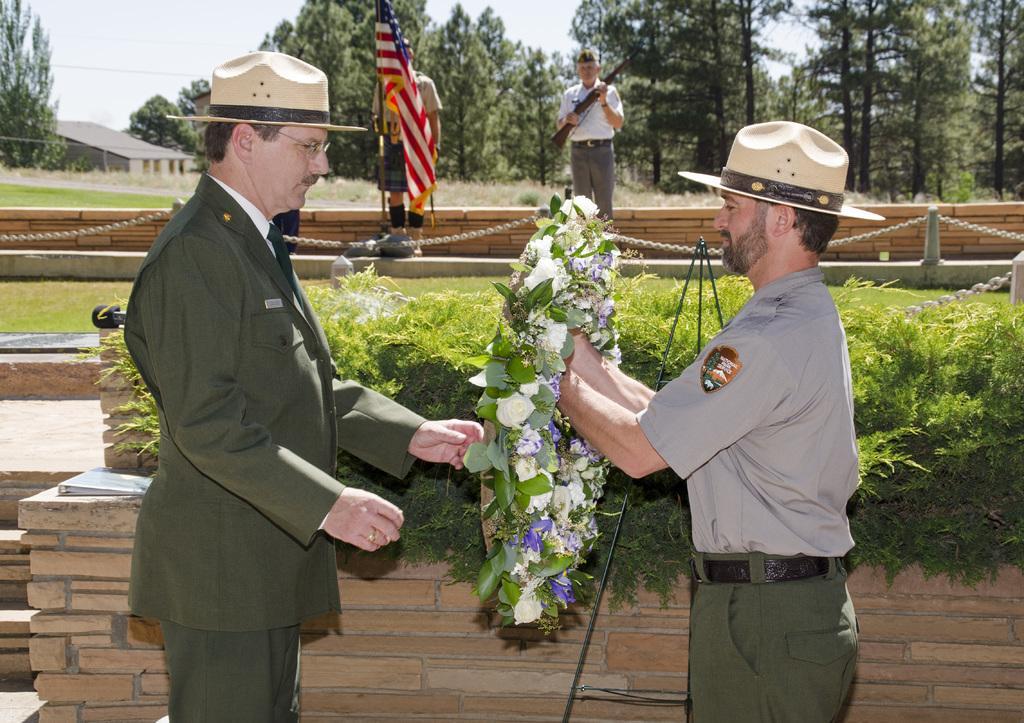In one or two sentences, can you explain what this image depicts? In the foreground I can see two persons are standing and one person is holding a garland in hand. In the background I can see plants, fence, grass and two persons are standing. On the top I can see trees and the sky. This image is taken during a day. 